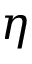<formula> <loc_0><loc_0><loc_500><loc_500>\eta</formula> 